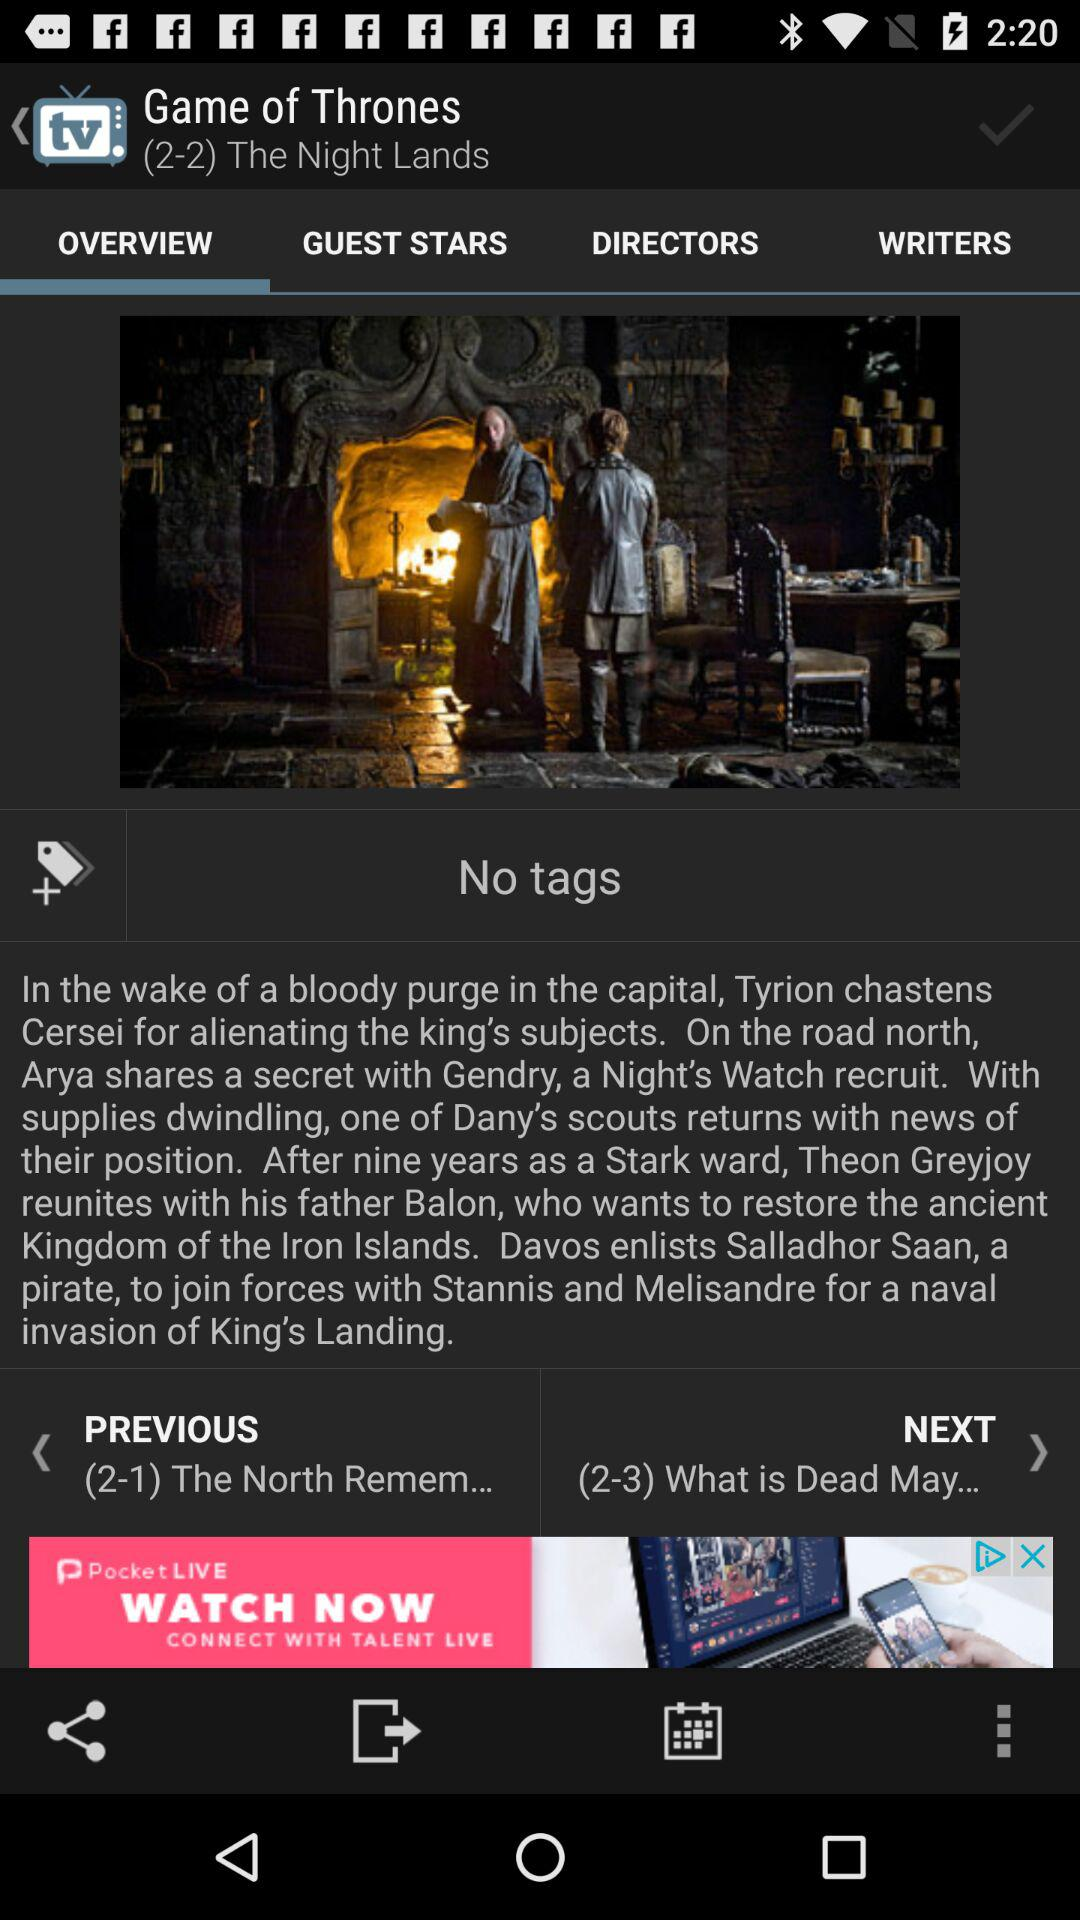Which tab is selected? The selected tab is "OVERVIEW". 